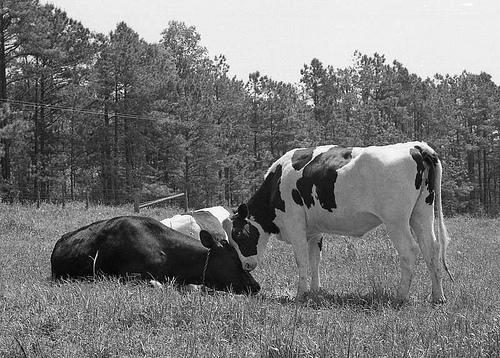Question: how many cows are there?
Choices:
A. Three.
B. Four.
C. Two.
D. Five.
Answer with the letter. Answer: C Question: who is eating?
Choices:
A. The cows.
B. The family.
C. The birds.
D. The children.
Answer with the letter. Answer: A Question: what color are the cows?
Choices:
A. Tan.
B. White and black.
C. Black.
D. White.
Answer with the letter. Answer: B Question: what do the cows lay on?
Choices:
A. Straw.
B. Ground.
C. Hay.
D. Grass.
Answer with the letter. Answer: D Question: where are the cows?
Choices:
A. In the pasture.
B. In the barn.
C. In the coral.
D. In a field.
Answer with the letter. Answer: D Question: when is this taken?
Choices:
A. Breakfast time.
B. Lunch time.
C. Dinner time.
D. During the day.
Answer with the letter. Answer: D 